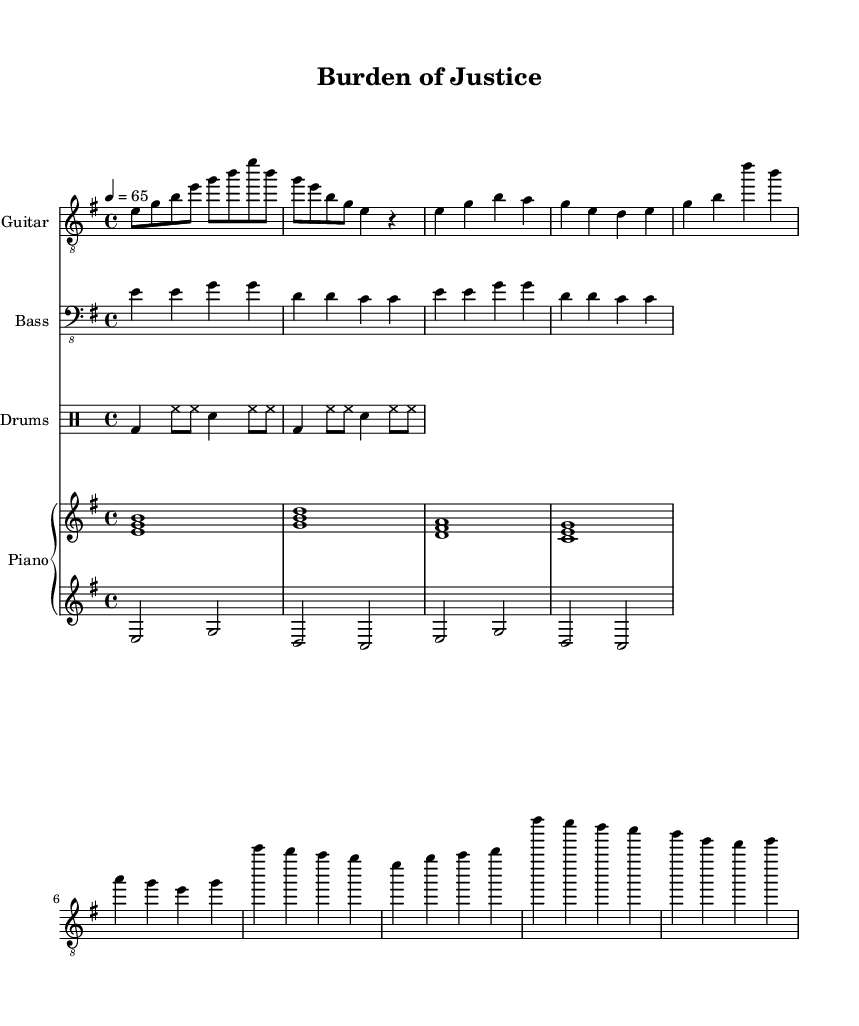What is the key signature of this music? The key signature is E minor, which is indicated by one sharp (F#) in the notation. This can be seen in the global section where the key is set.
Answer: E minor What is the time signature of this music? The time signature is 4/4, which indicates there are four beats in each measure. This is shown in the global section of the code where the time is defined.
Answer: 4/4 What is the tempo marking indicated for this piece? The tempo marking is 65 beats per minute, which specifies the speed of the music. It is found in the global section as the tempo instruction.
Answer: 65 How many measures are in the verse section? The verse section consists of four measures, as each line segment indicated in the electric guitar part contains two measures of music, and there are two lines for the verse. Counting those gives a total of four measures.
Answer: 4 What type of guitar is used in this score? The score specifies that the instrument is an electric guitar, which is indicated in the staff naming. This reflects the typical instrumentation common in rock music.
Answer: Electric Guitar Identify the chord progression for the verse. The chord progression for the verse is E, G, D, and C, which corresponds to the specified chord symbols placed above the piano right hand in this section. The chords are arranged in a sequential format playable by the right hand on piano.
Answer: E, G, D, C How many instruments are featured in the score? There are four distinct instruments featured in the score: Electric Guitar, Bass, Drums, and Piano (divided into left and right hands). This is visible in the score sections titled for each instrument.
Answer: 4 